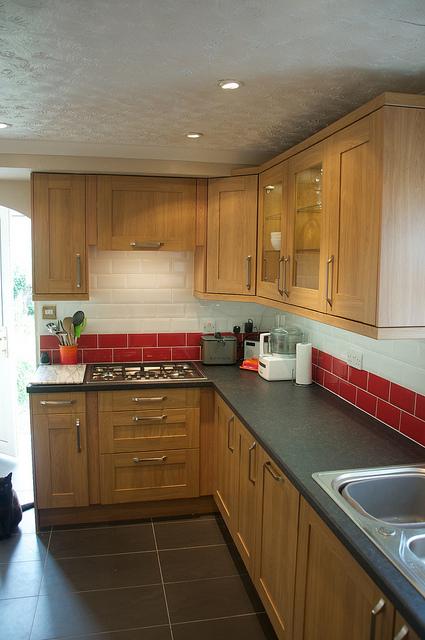What room is photographed?
Answer briefly. Kitchen. What material is the sink made from?
Answer briefly. Metal. Are there red tiles on the wall below the cabinets?
Keep it brief. Yes. 